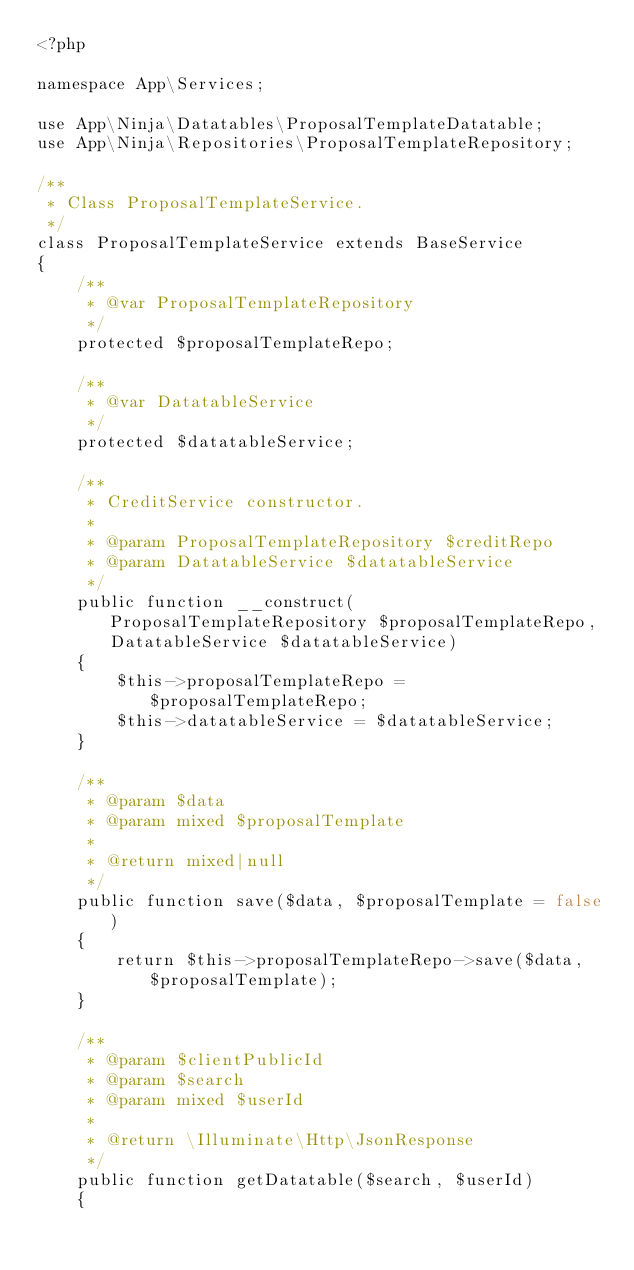Convert code to text. <code><loc_0><loc_0><loc_500><loc_500><_PHP_><?php

namespace App\Services;

use App\Ninja\Datatables\ProposalTemplateDatatable;
use App\Ninja\Repositories\ProposalTemplateRepository;

/**
 * Class ProposalTemplateService.
 */
class ProposalTemplateService extends BaseService
{
    /**
     * @var ProposalTemplateRepository
     */
    protected $proposalTemplateRepo;

    /**
     * @var DatatableService
     */
    protected $datatableService;

    /**
     * CreditService constructor.
     *
     * @param ProposalTemplateRepository $creditRepo
     * @param DatatableService $datatableService
     */
    public function __construct(ProposalTemplateRepository $proposalTemplateRepo, DatatableService $datatableService)
    {
        $this->proposalTemplateRepo = $proposalTemplateRepo;
        $this->datatableService = $datatableService;
    }

    /**
     * @param $data
     * @param mixed $proposalTemplate
     *
     * @return mixed|null
     */
    public function save($data, $proposalTemplate = false)
    {
        return $this->proposalTemplateRepo->save($data, $proposalTemplate);
    }

    /**
     * @param $clientPublicId
     * @param $search
     * @param mixed $userId
     *
     * @return \Illuminate\Http\JsonResponse
     */
    public function getDatatable($search, $userId)
    {</code> 